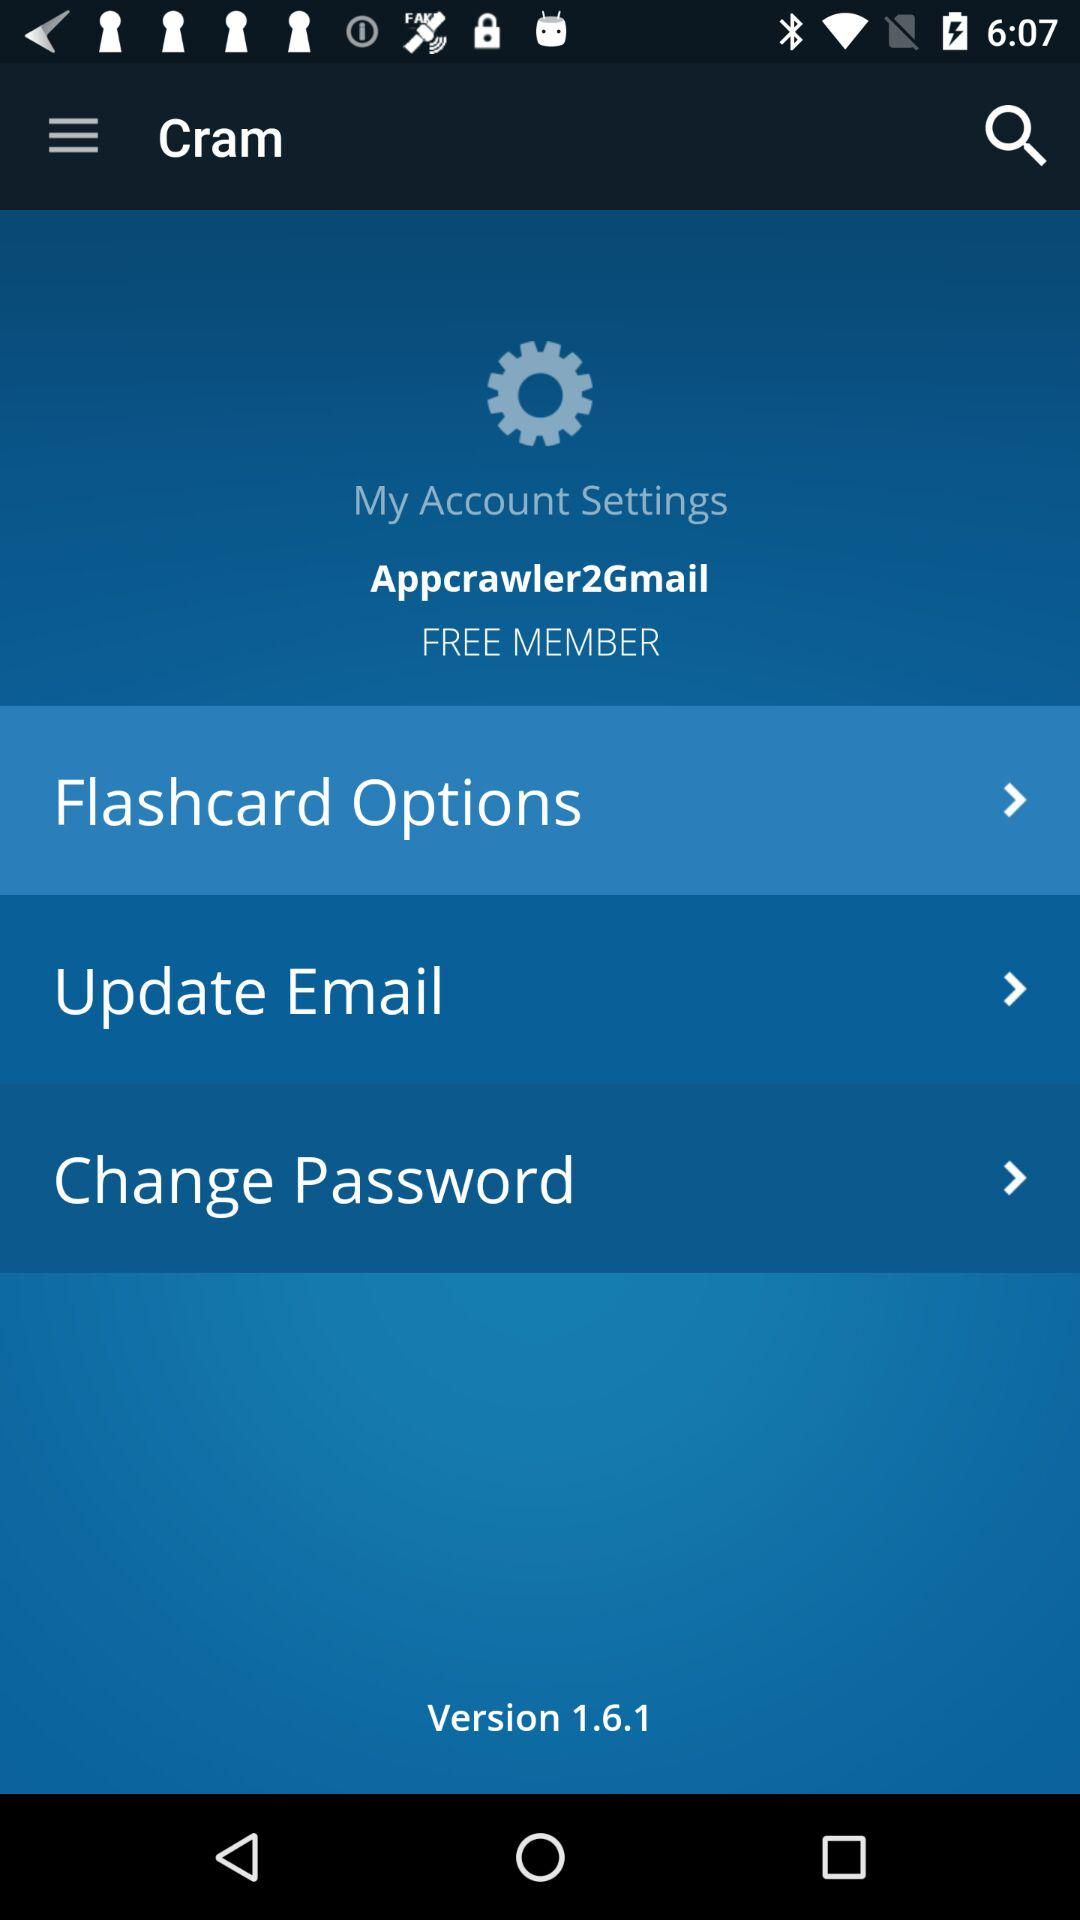How many options are displayed on the My Account Settings screen?
Answer the question using a single word or phrase. 3 